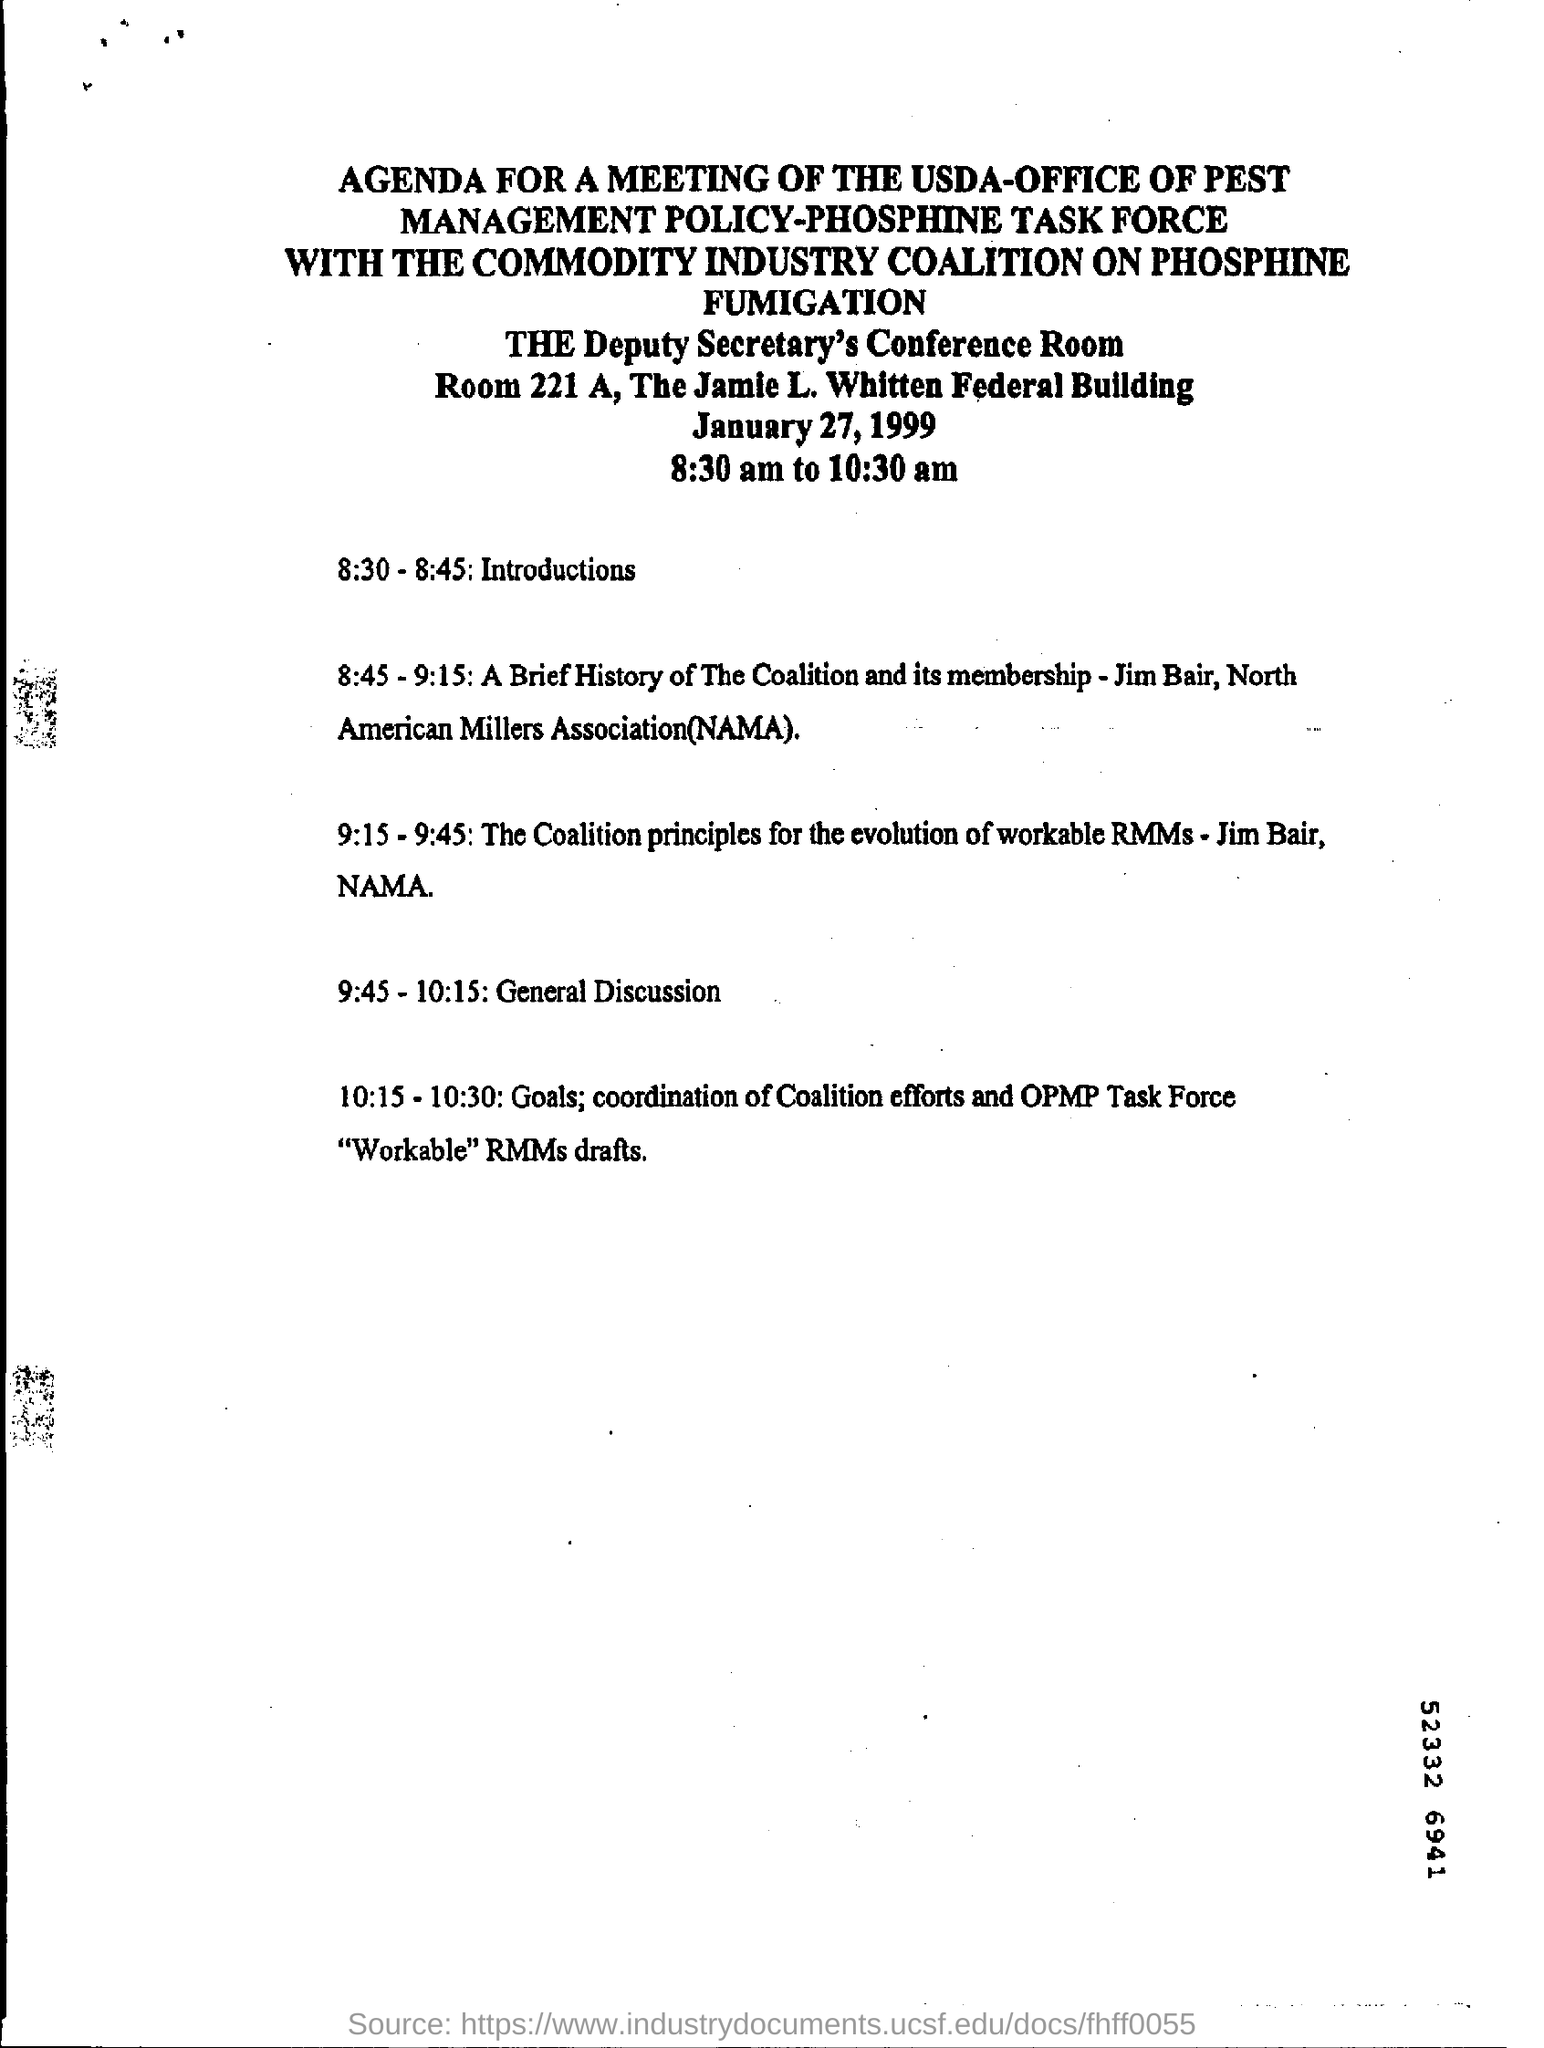As per this agenda printed in which room is the meeting conducted?
Your response must be concise. THE Deputy Secretary's Conference Room. What is functioning in Room 221 A?
Ensure brevity in your answer.  Deputy Secretary's Conference Room. What is date of meeting as per agenda notice?
Offer a terse response. January 27, 1999. What time is the meeting?
Your answer should be very brief. 8:30 am to 10:30 am. As per this agenda what time is the introductions?
Your answer should be very brief. 8:30 - 8:45. 